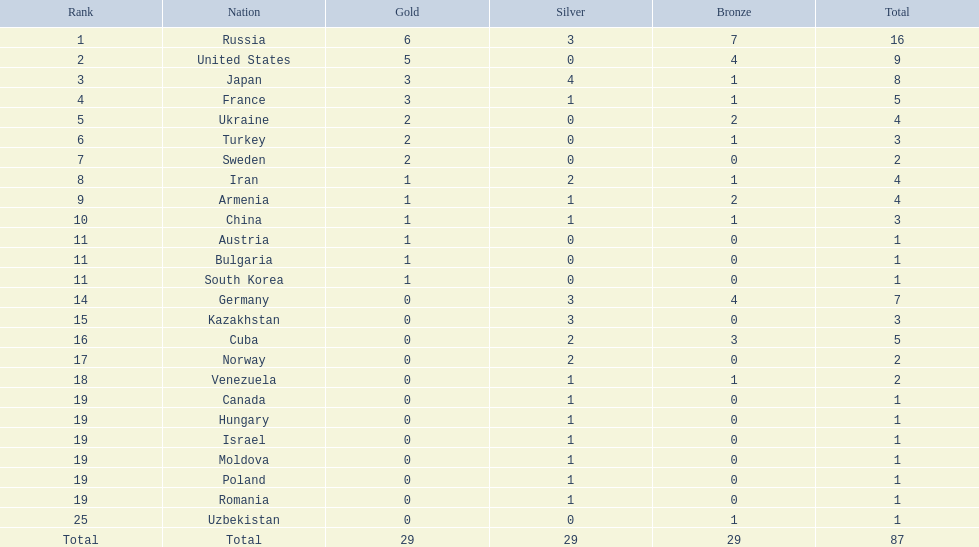What were the nation-states participating in the 1995 world wrestling championships? Russia, United States, Japan, France, Ukraine, Turkey, Sweden, Iran, Armenia, China, Austria, Bulgaria, South Korea, Germany, Kazakhstan, Cuba, Norway, Venezuela, Canada, Hungary, Israel, Moldova, Poland, Romania, Uzbekistan. How many gold trophies did the united states attain in the championship? 5. Give me the full table as a dictionary. {'header': ['Rank', 'Nation', 'Gold', 'Silver', 'Bronze', 'Total'], 'rows': [['1', 'Russia', '6', '3', '7', '16'], ['2', 'United States', '5', '0', '4', '9'], ['3', 'Japan', '3', '4', '1', '8'], ['4', 'France', '3', '1', '1', '5'], ['5', 'Ukraine', '2', '0', '2', '4'], ['6', 'Turkey', '2', '0', '1', '3'], ['7', 'Sweden', '2', '0', '0', '2'], ['8', 'Iran', '1', '2', '1', '4'], ['9', 'Armenia', '1', '1', '2', '4'], ['10', 'China', '1', '1', '1', '3'], ['11', 'Austria', '1', '0', '0', '1'], ['11', 'Bulgaria', '1', '0', '0', '1'], ['11', 'South Korea', '1', '0', '0', '1'], ['14', 'Germany', '0', '3', '4', '7'], ['15', 'Kazakhstan', '0', '3', '0', '3'], ['16', 'Cuba', '0', '2', '3', '5'], ['17', 'Norway', '0', '2', '0', '2'], ['18', 'Venezuela', '0', '1', '1', '2'], ['19', 'Canada', '0', '1', '0', '1'], ['19', 'Hungary', '0', '1', '0', '1'], ['19', 'Israel', '0', '1', '0', '1'], ['19', 'Moldova', '0', '1', '0', '1'], ['19', 'Poland', '0', '1', '0', '1'], ['19', 'Romania', '0', '1', '0', '1'], ['25', 'Uzbekistan', '0', '0', '1', '1'], ['Total', 'Total', '29', '29', '29', '87']]} What total of medals earner surpassed this value? 6. What country received these medals? Russia. 